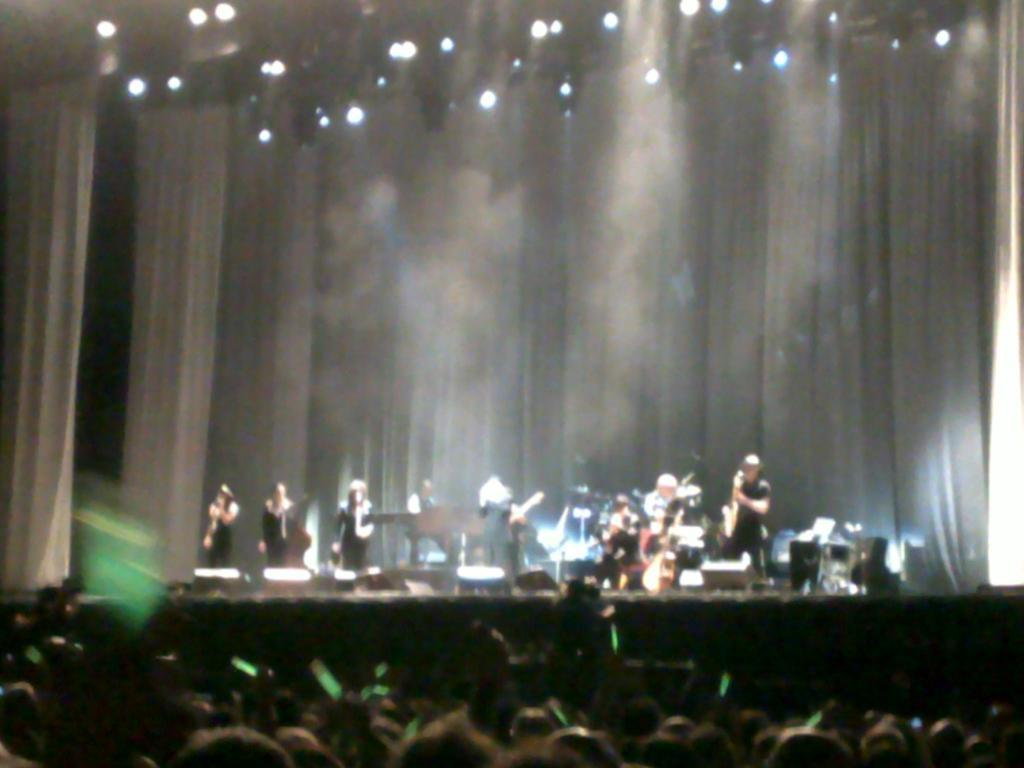What is happening in the image involving a group of people? There is a group of people in the image, and they are standing on a stage. What are the people on the stage doing? The people on the stage are playing musical instruments. What can be seen in the image that provides lighting? There are lights visible in the image. Can you see a river flowing in the background of the image? There is no river visible in the image. 